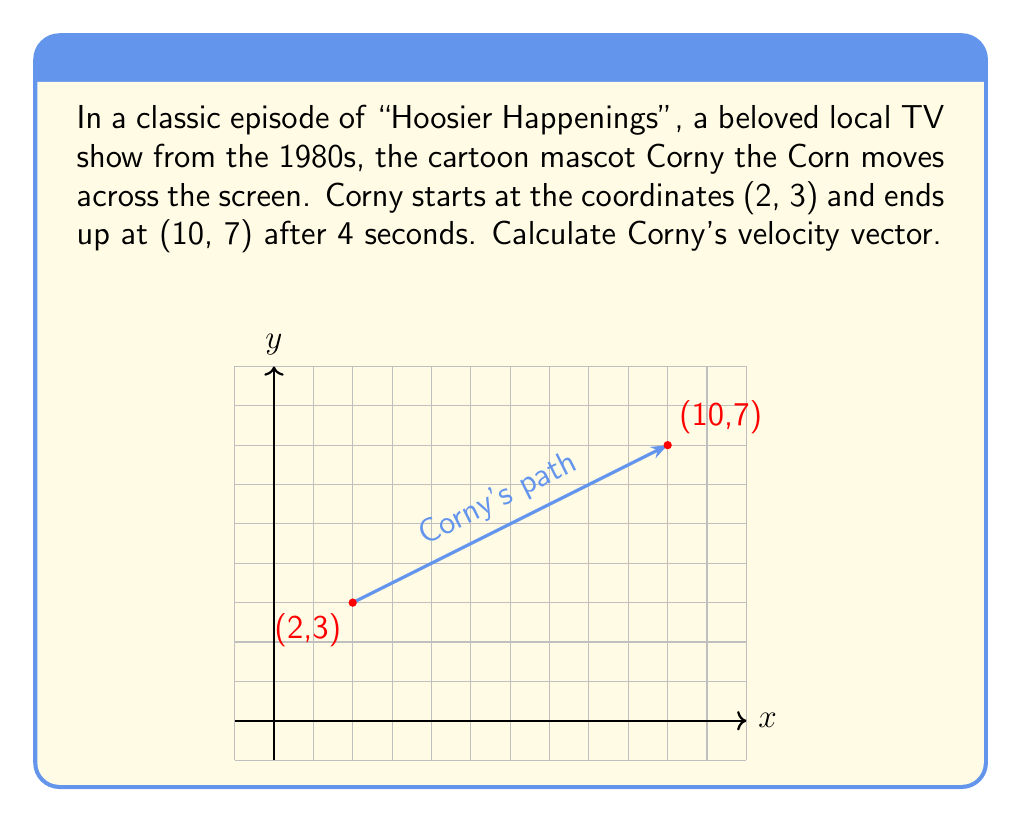Can you solve this math problem? Let's approach this step-by-step:

1) The velocity vector is defined as the displacement vector divided by the time taken.

2) First, we need to find the displacement vector:
   - Initial position: $(x_1, y_1) = (2, 3)$
   - Final position: $(x_2, y_2) = (10, 7)$
   - Displacement vector: $\vec{d} = (x_2 - x_1, y_2 - y_1) = (10 - 2, 7 - 3) = (8, 4)$

3) Now, we have:
   - Displacement vector: $\vec{d} = (8, 4)$
   - Time taken: $t = 4$ seconds

4) The velocity vector $\vec{v}$ is given by:

   $$\vec{v} = \frac{\vec{d}}{t} = \frac{(8, 4)}{4}$$

5) Dividing each component by 4:

   $$\vec{v} = (2, 1)$$

Therefore, Corny's velocity vector is $(2, 1)$ units per second.
Answer: $(2, 1)$ units/s 